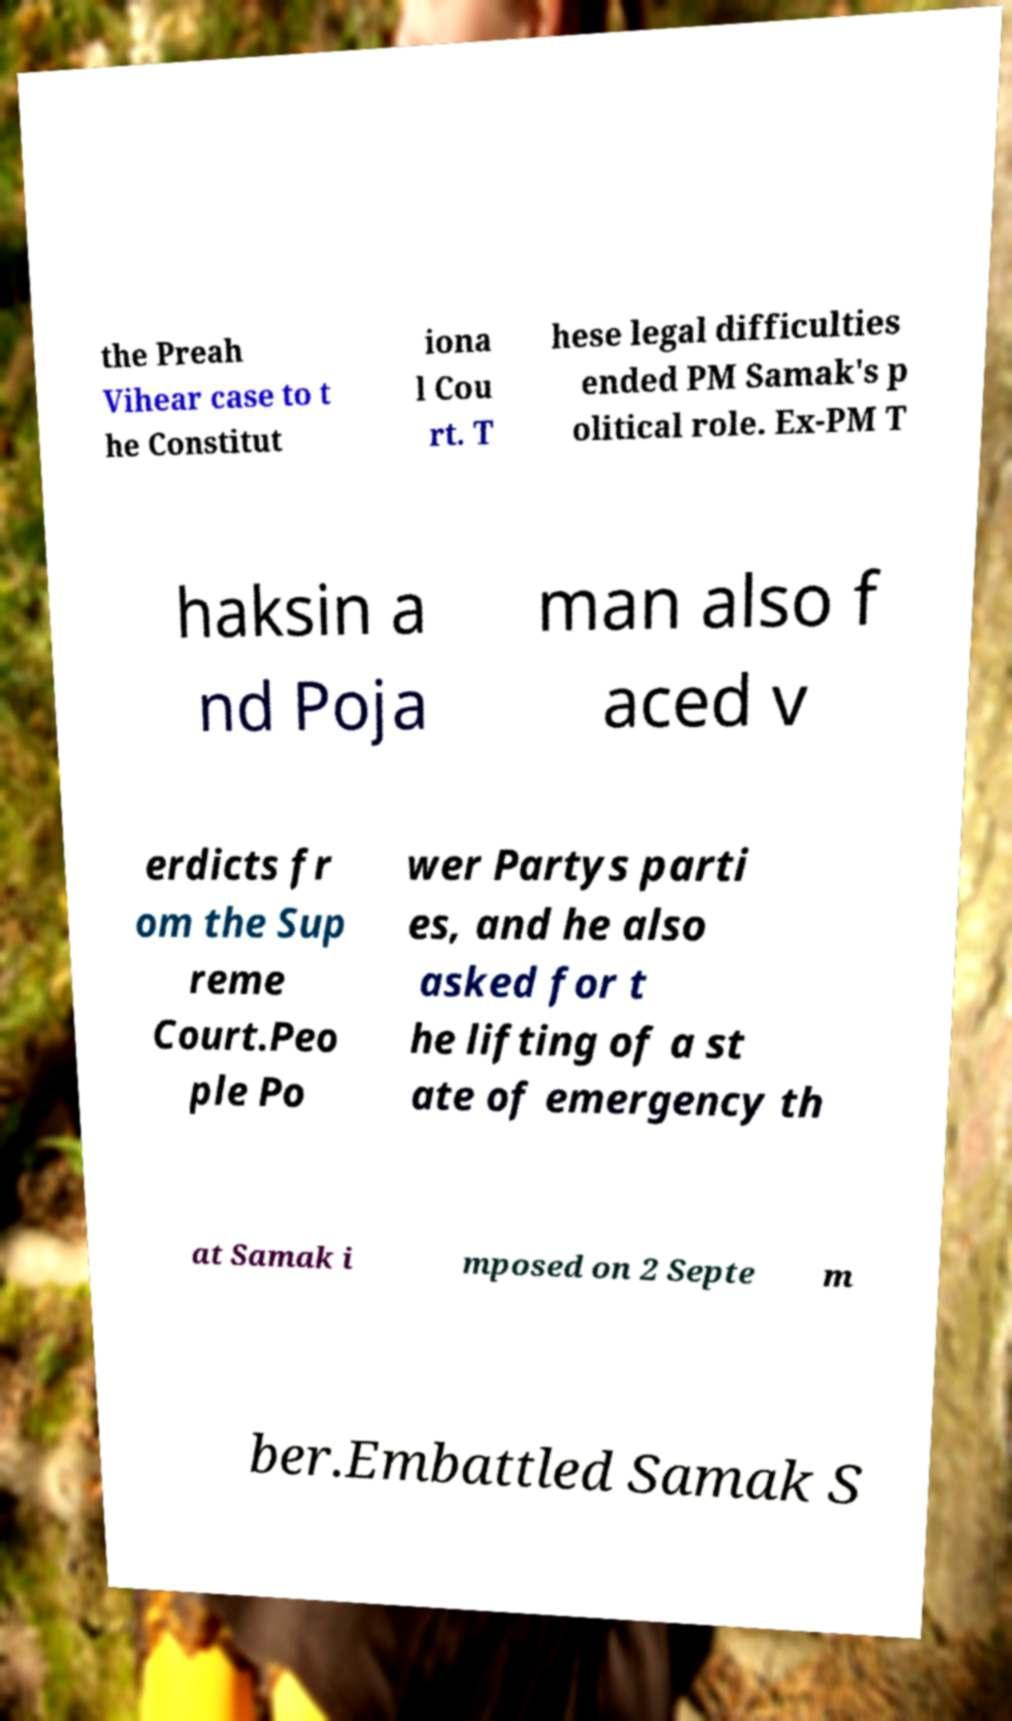Could you assist in decoding the text presented in this image and type it out clearly? the Preah Vihear case to t he Constitut iona l Cou rt. T hese legal difficulties ended PM Samak's p olitical role. Ex-PM T haksin a nd Poja man also f aced v erdicts fr om the Sup reme Court.Peo ple Po wer Partys parti es, and he also asked for t he lifting of a st ate of emergency th at Samak i mposed on 2 Septe m ber.Embattled Samak S 